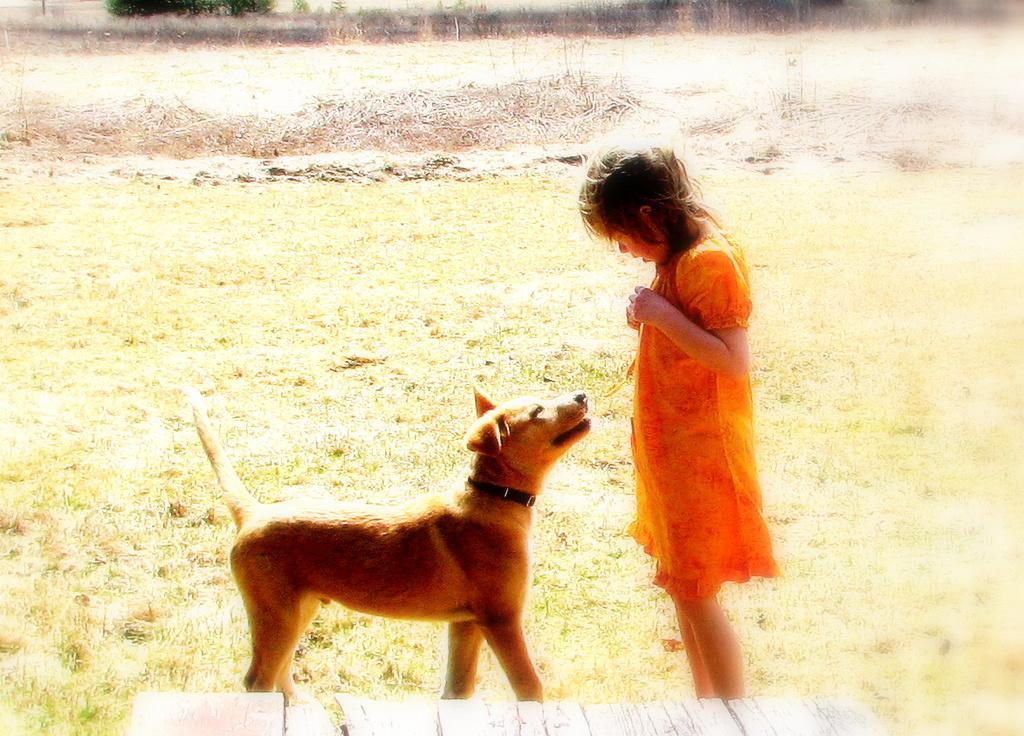Could you give a brief overview of what you see in this image? This image is clicked in a open space. To the right, there is a girl, she is wearing a orange dress. In front of her, there is a brown dog, and a black belt is tied to its neck. At the bottom, there is a bench made up of wood. In the background, there is brown grass which is dried. 